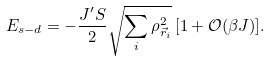<formula> <loc_0><loc_0><loc_500><loc_500>E _ { s - d } = - \frac { J ^ { \prime } S } { 2 } \sqrt { \sum _ { i } \rho _ { \vec { r } _ { i } } ^ { 2 } } \, [ 1 + { \mathcal { O } } ( \beta J ) ] .</formula> 